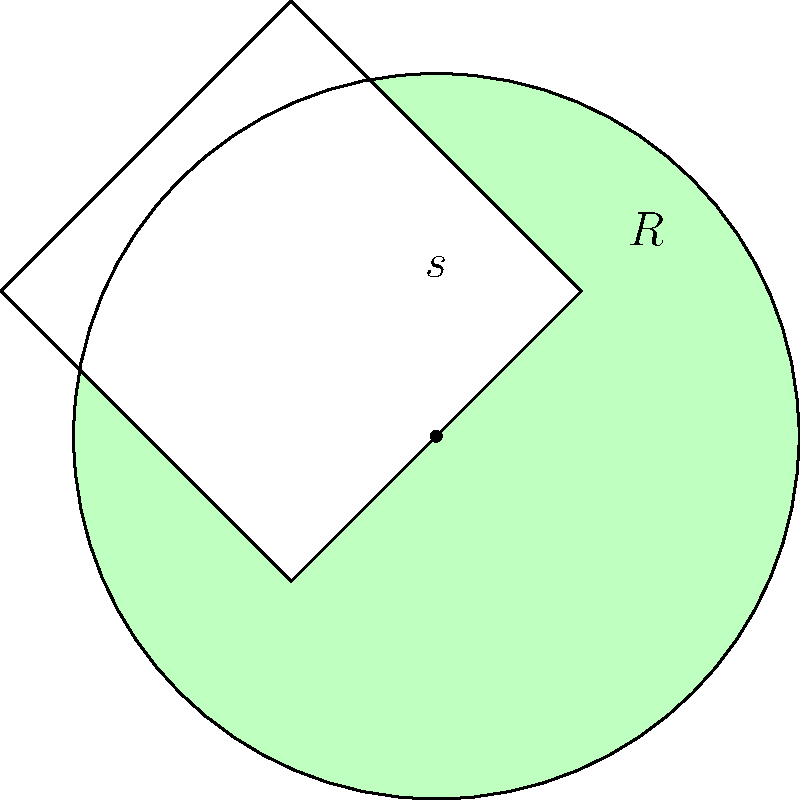In ancient China, a jade craftsman is creating a circular disc with a square hole in the center. The outer radius of the disc is $R$ and the side length of the square hole is $s$. If $R = 5$ cm and $s = 4$ cm, what is the area of the jade disc in square centimeters? To find the area of the jade disc, we need to:

1. Calculate the area of the full circle:
   $$A_{circle} = \pi R^2 = \pi (5\text{ cm})^2 = 25\pi\text{ cm}^2$$

2. Calculate the area of the square hole:
   $$A_{square} = s^2 = (4\text{ cm})^2 = 16\text{ cm}^2$$

3. Subtract the area of the square hole from the area of the full circle:
   $$A_{jade} = A_{circle} - A_{square} = 25\pi\text{ cm}^2 - 16\text{ cm}^2$$

4. Simplify:
   $$A_{jade} = 25\pi - 16\text{ cm}^2 \approx 62.54\text{ cm}^2$$

Therefore, the area of the jade disc is approximately 62.54 square centimeters.
Answer: $25\pi - 16 \approx 62.54\text{ cm}^2$ 